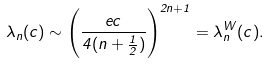Convert formula to latex. <formula><loc_0><loc_0><loc_500><loc_500>\lambda _ { n } ( c ) \sim \left ( \frac { e c } { 4 ( n + \frac { 1 } { 2 } ) } \right ) ^ { 2 n + 1 } = \lambda _ { n } ^ { W } ( c ) .</formula> 